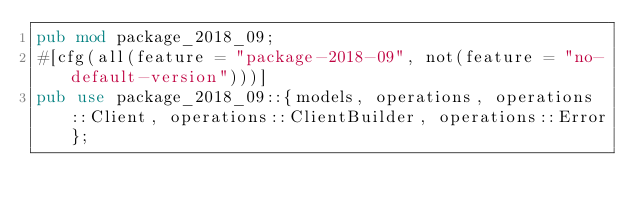<code> <loc_0><loc_0><loc_500><loc_500><_Rust_>pub mod package_2018_09;
#[cfg(all(feature = "package-2018-09", not(feature = "no-default-version")))]
pub use package_2018_09::{models, operations, operations::Client, operations::ClientBuilder, operations::Error};
</code> 